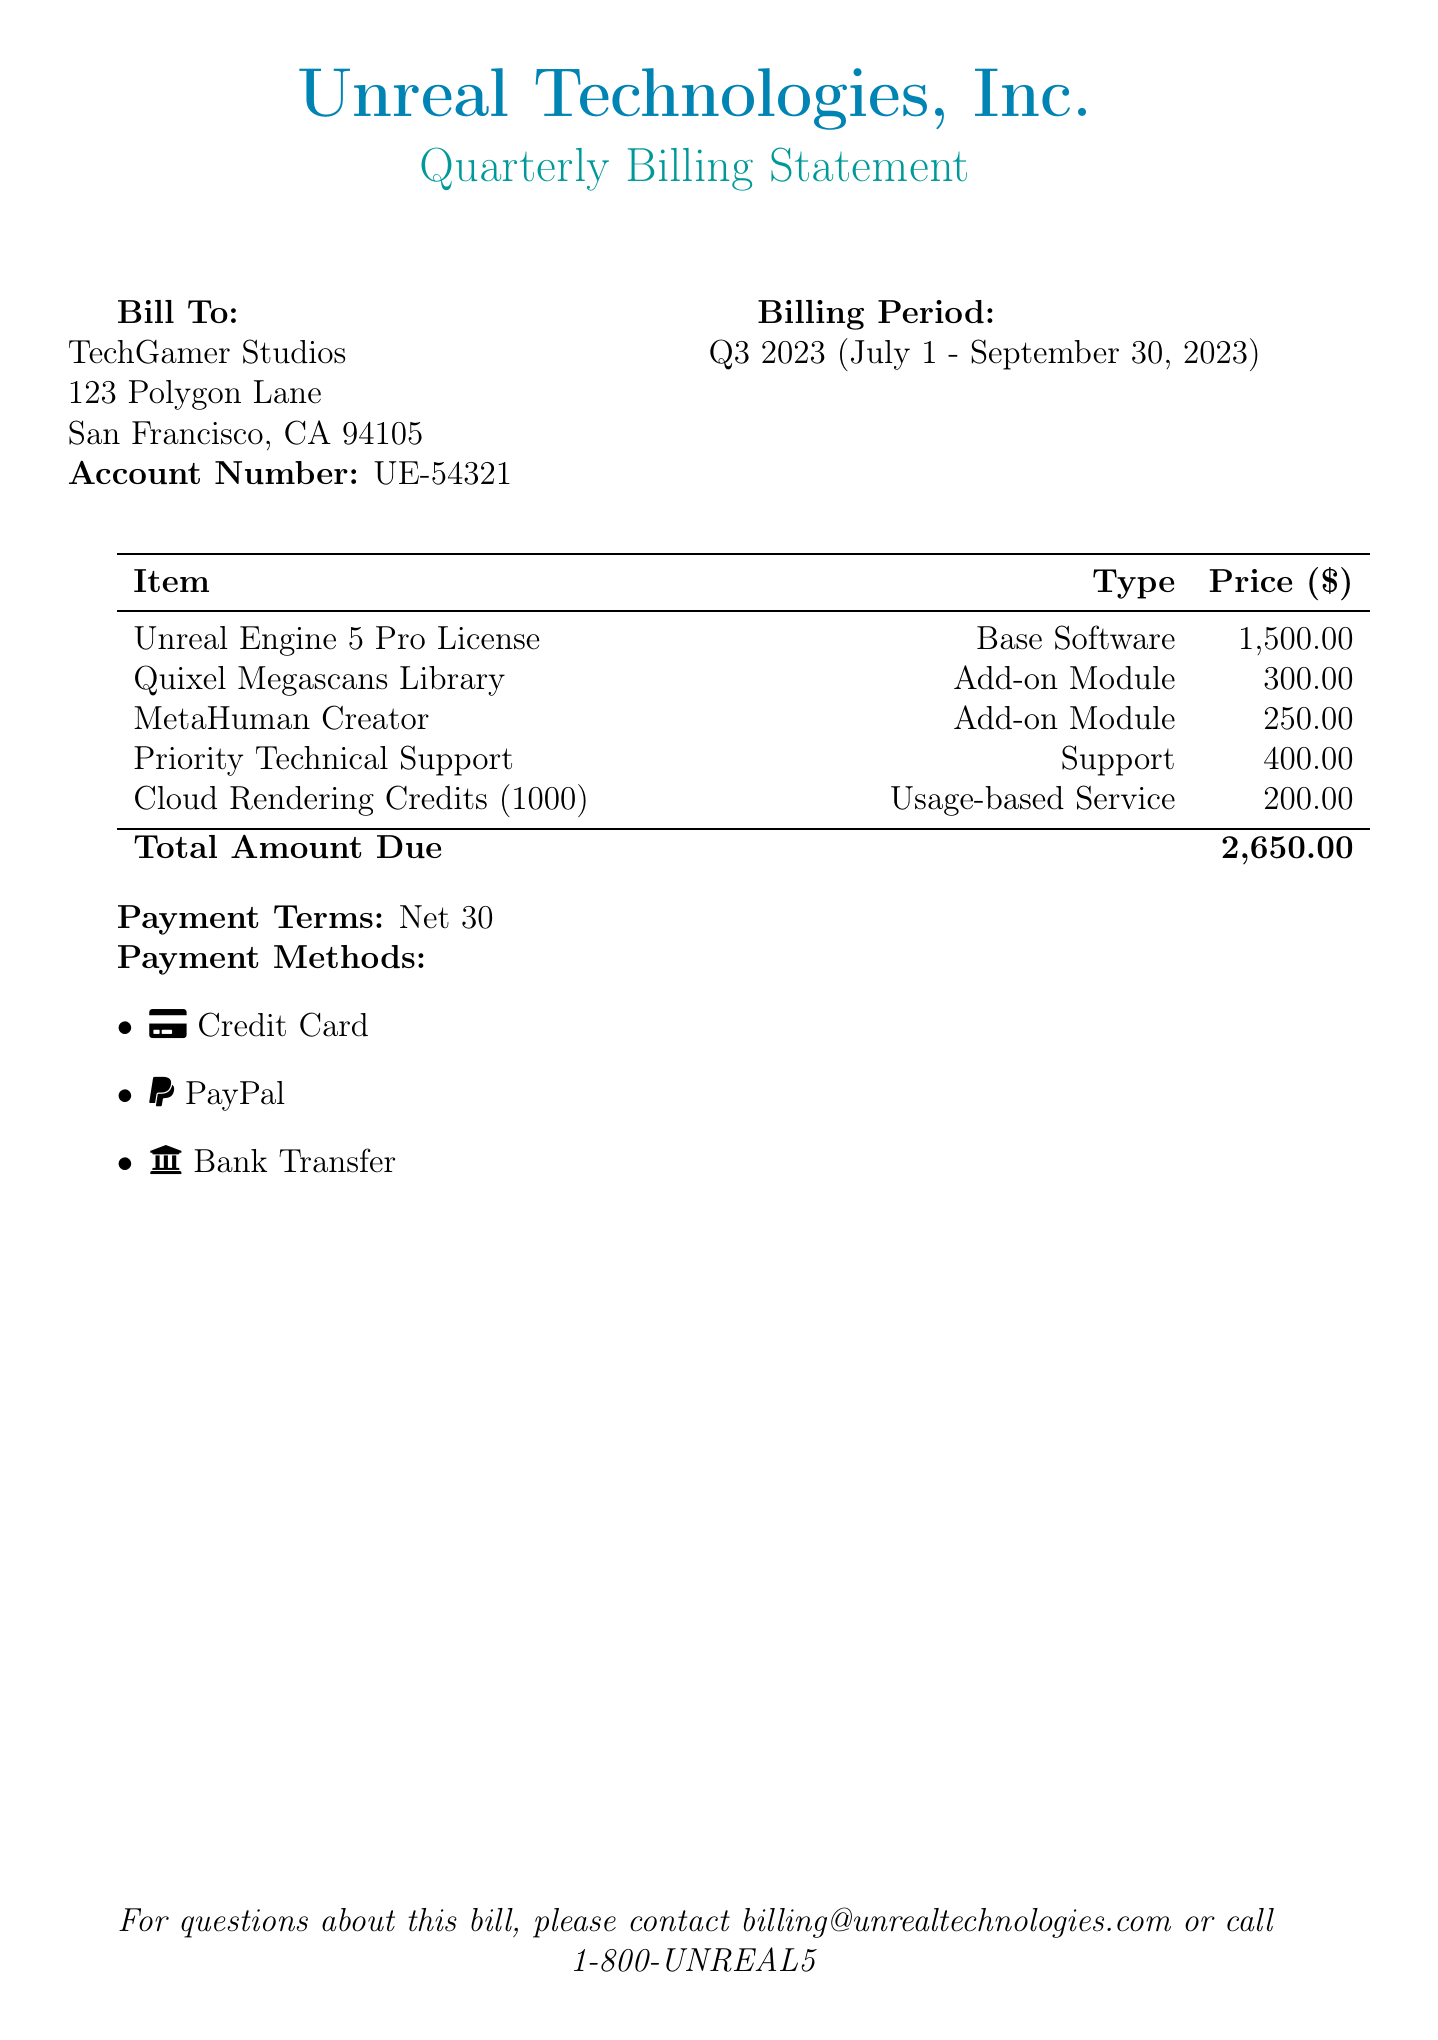what is the total amount due? The total amount due is listed at the bottom of the billing statement.
Answer: 2,650.00 what is the account number? The account number is specified in the billing address section of the document.
Answer: UE-54321 who is the bill addressed to? The bill identifies the recipient in the "Bill To" section.
Answer: TechGamer Studios what is the billing period? The billing period is indicated in the document, specifying the time frame covered by the bill.
Answer: Q3 2023 (July 1 - September 30, 2023) what type of support is included in the statement? The document specifies the nature of the included services in the support section.
Answer: Priority Technical Support how many cloud rendering credits are included? The number of cloud rendering credits is indicated as a usage-based service in the itemized list.
Answer: 1000 what are the payment terms? The payment terms are outlined explicitly in the document, indicating when the payment is due.
Answer: Net 30 what payment methods are accepted? The document lists various payment options available for the user to make the payment.
Answer: Credit Card, PayPal, Bank Transfer what is the price of the MetaHuman Creator? The itemization lists the price of the MetaHuman Creator explicitly.
Answer: 250.00 